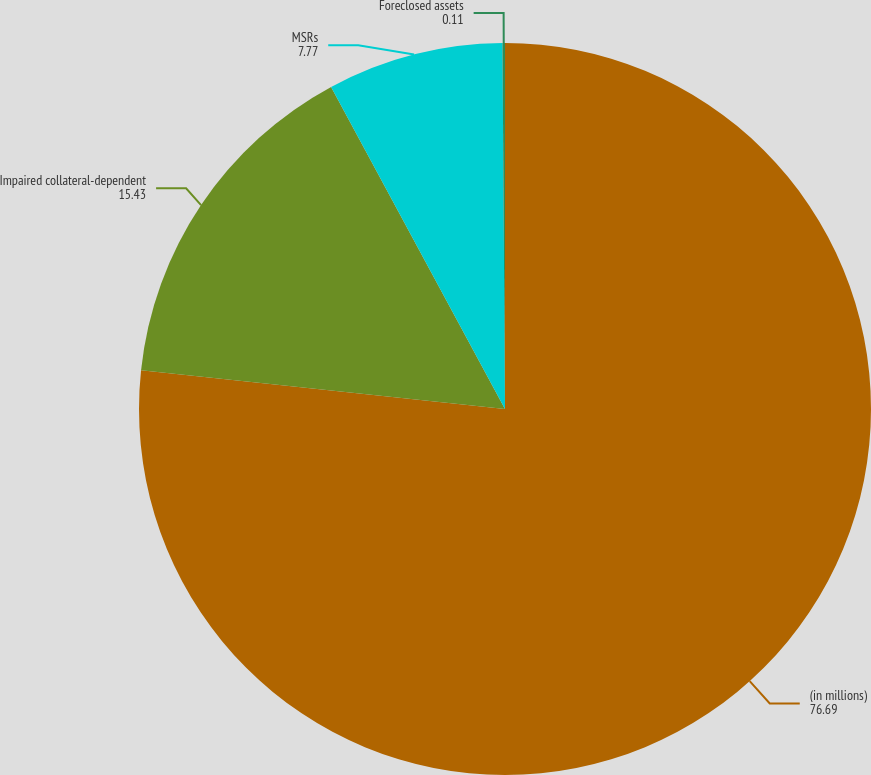Convert chart. <chart><loc_0><loc_0><loc_500><loc_500><pie_chart><fcel>(in millions)<fcel>Impaired collateral-dependent<fcel>MSRs<fcel>Foreclosed assets<nl><fcel>76.69%<fcel>15.43%<fcel>7.77%<fcel>0.11%<nl></chart> 